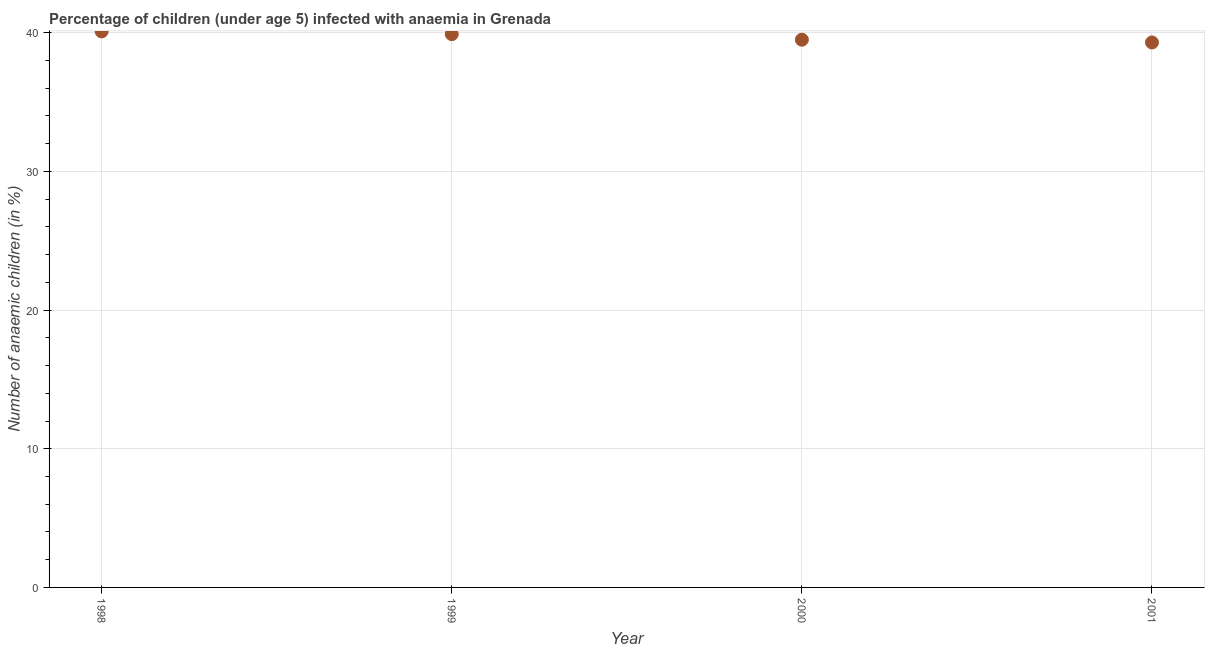What is the number of anaemic children in 2001?
Provide a succinct answer. 39.3. Across all years, what is the maximum number of anaemic children?
Provide a succinct answer. 40.1. Across all years, what is the minimum number of anaemic children?
Make the answer very short. 39.3. In which year was the number of anaemic children maximum?
Ensure brevity in your answer.  1998. What is the sum of the number of anaemic children?
Keep it short and to the point. 158.8. What is the difference between the number of anaemic children in 1999 and 2000?
Provide a short and direct response. 0.4. What is the average number of anaemic children per year?
Make the answer very short. 39.7. What is the median number of anaemic children?
Your response must be concise. 39.7. In how many years, is the number of anaemic children greater than 6 %?
Your response must be concise. 4. What is the ratio of the number of anaemic children in 1998 to that in 2000?
Your answer should be very brief. 1.02. Is the number of anaemic children in 1998 less than that in 2001?
Ensure brevity in your answer.  No. What is the difference between the highest and the second highest number of anaemic children?
Your answer should be very brief. 0.2. Is the sum of the number of anaemic children in 1998 and 2000 greater than the maximum number of anaemic children across all years?
Give a very brief answer. Yes. What is the difference between the highest and the lowest number of anaemic children?
Provide a short and direct response. 0.8. How many dotlines are there?
Provide a succinct answer. 1. What is the difference between two consecutive major ticks on the Y-axis?
Your answer should be compact. 10. What is the title of the graph?
Offer a terse response. Percentage of children (under age 5) infected with anaemia in Grenada. What is the label or title of the X-axis?
Your answer should be very brief. Year. What is the label or title of the Y-axis?
Provide a short and direct response. Number of anaemic children (in %). What is the Number of anaemic children (in %) in 1998?
Offer a terse response. 40.1. What is the Number of anaemic children (in %) in 1999?
Make the answer very short. 39.9. What is the Number of anaemic children (in %) in 2000?
Your response must be concise. 39.5. What is the Number of anaemic children (in %) in 2001?
Provide a short and direct response. 39.3. What is the difference between the Number of anaemic children (in %) in 1998 and 2000?
Your answer should be very brief. 0.6. What is the difference between the Number of anaemic children (in %) in 1999 and 2001?
Provide a short and direct response. 0.6. What is the ratio of the Number of anaemic children (in %) in 1998 to that in 1999?
Make the answer very short. 1. What is the ratio of the Number of anaemic children (in %) in 1998 to that in 2000?
Give a very brief answer. 1.01. What is the ratio of the Number of anaemic children (in %) in 1998 to that in 2001?
Ensure brevity in your answer.  1.02. 